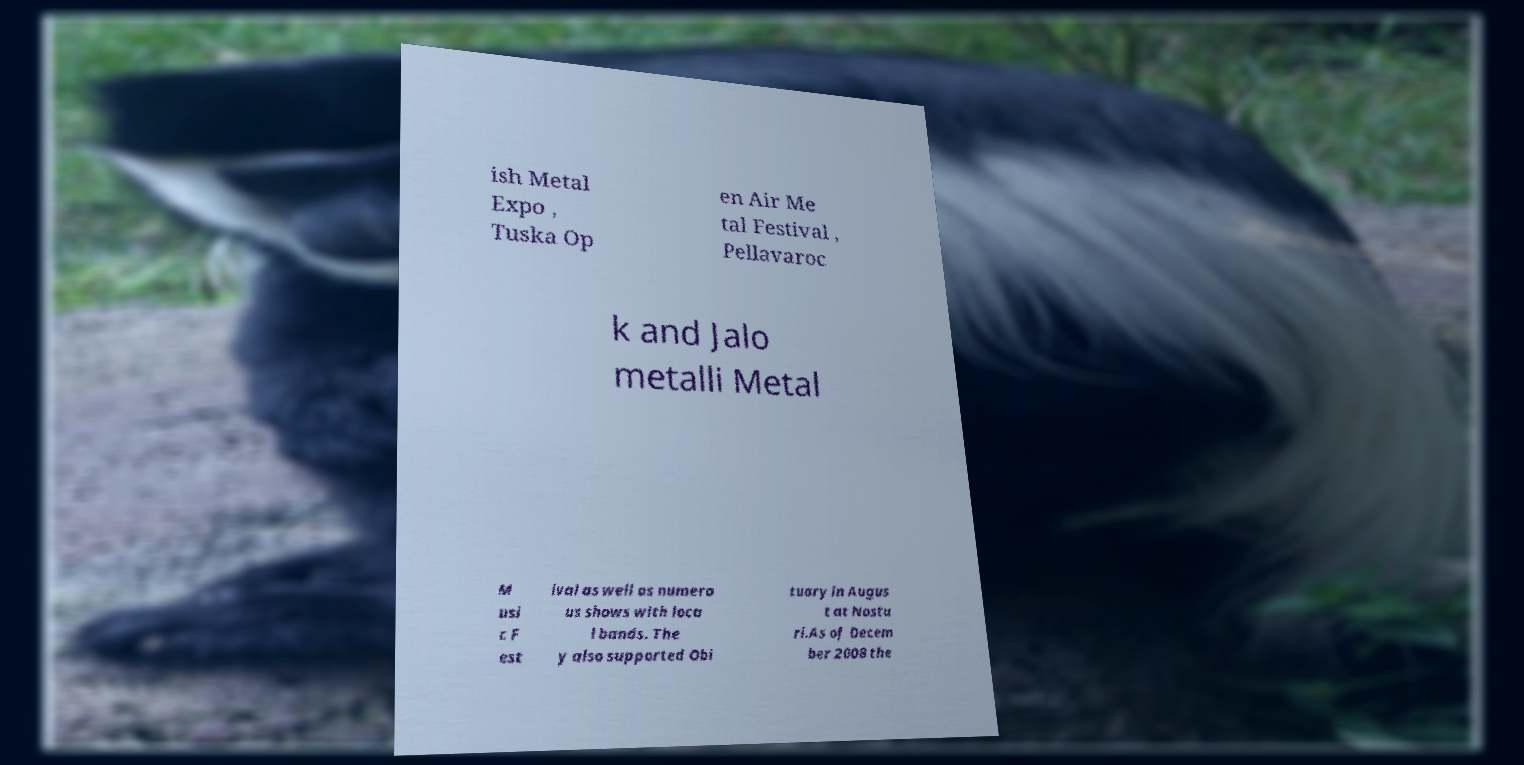Please read and relay the text visible in this image. What does it say? ish Metal Expo , Tuska Op en Air Me tal Festival , Pellavaroc k and Jalo metalli Metal M usi c F est ival as well as numero us shows with loca l bands. The y also supported Obi tuary in Augus t at Nostu ri.As of Decem ber 2008 the 